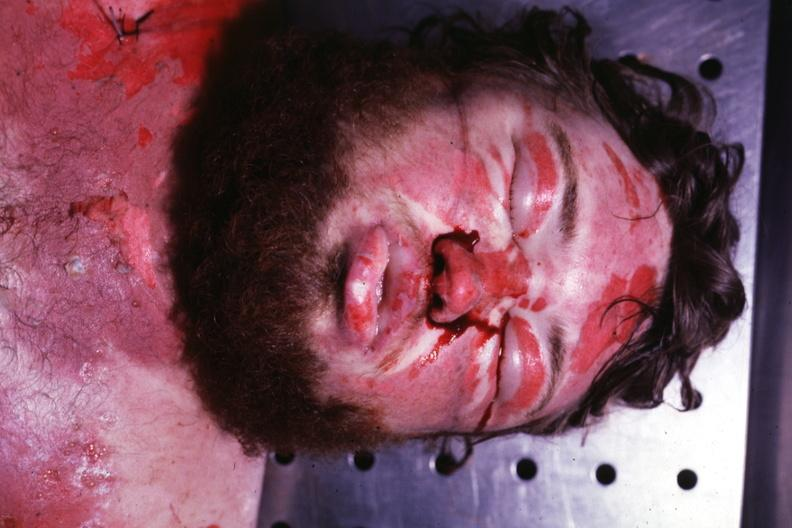what does this image show?
Answer the question using a single word or phrase. Severe body burns 24 hours anasarca 